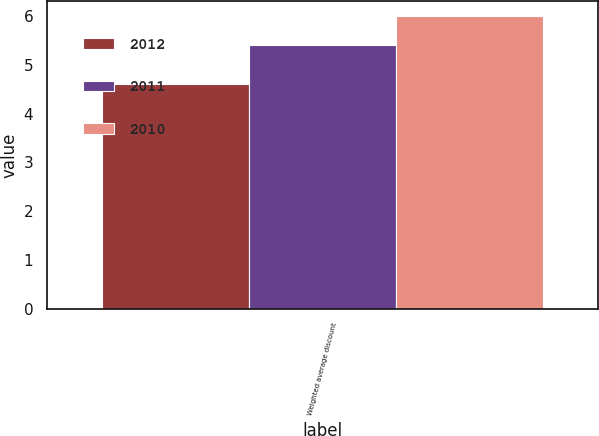Convert chart to OTSL. <chart><loc_0><loc_0><loc_500><loc_500><stacked_bar_chart><ecel><fcel>Weighted average discount<nl><fcel>2012<fcel>4.6<nl><fcel>2011<fcel>5.4<nl><fcel>2010<fcel>6<nl></chart> 